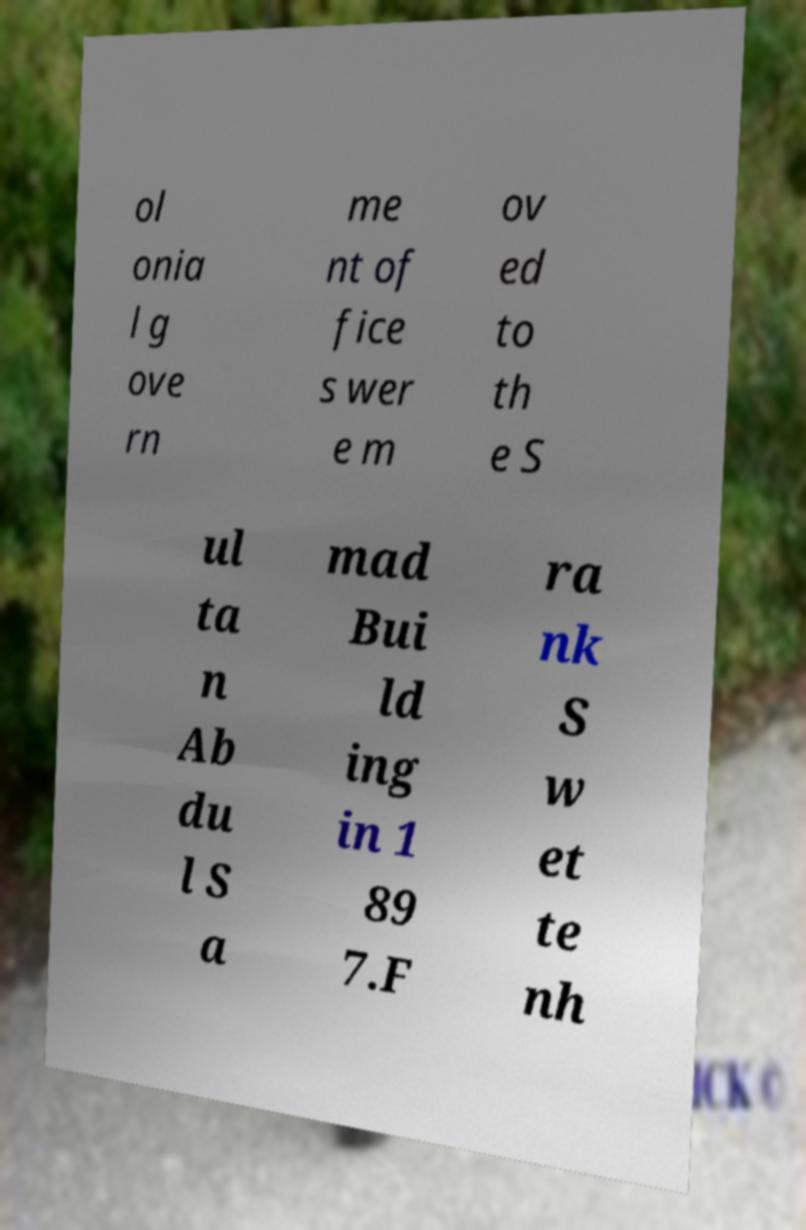Can you accurately transcribe the text from the provided image for me? ol onia l g ove rn me nt of fice s wer e m ov ed to th e S ul ta n Ab du l S a mad Bui ld ing in 1 89 7.F ra nk S w et te nh 